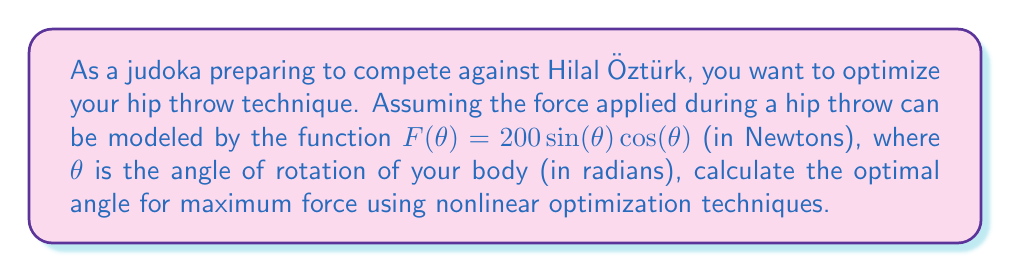Help me with this question. To find the optimal angle for maximum force, we need to maximize the function $F(\theta) = 200\sin(\theta)\cos(\theta)$. Let's approach this step-by-step:

1) First, we can simplify the function using the trigonometric identity $\sin(2\theta) = 2\sin(\theta)\cos(\theta)$:

   $F(\theta) = 200\sin(\theta)\cos(\theta) = 100\sin(2\theta)$

2) To find the maximum, we need to find where the derivative of $F(\theta)$ equals zero:

   $F'(\theta) = 100(2\cos(2\theta)) = 200\cos(2\theta)$

3) Set this equal to zero:

   $200\cos(2\theta) = 0$
   $\cos(2\theta) = 0$

4) The cosine function is zero when its argument is $\frac{\pi}{2}$ or $\frac{3\pi}{2}$. So:

   $2\theta = \frac{\pi}{2}$ or $2\theta = \frac{3\pi}{2}$
   $\theta = \frac{\pi}{4}$ or $\theta = \frac{3\pi}{4}$

5) To determine which of these gives the maximum (rather than minimum), we can check the second derivative:

   $F''(\theta) = -400\sin(2\theta)$

6) At $\theta = \frac{\pi}{4}$, $F''(\frac{\pi}{4}) = -400\sin(\frac{\pi}{2}) = -400 < 0$, indicating a maximum.
   At $\theta = \frac{3\pi}{4}$, $F''(\frac{3\pi}{4}) = -400\sin(\frac{3\pi}{2}) = 400 > 0$, indicating a minimum.

Therefore, the optimal angle for maximum force is $\frac{\pi}{4}$ radians or 45 degrees.
Answer: $\frac{\pi}{4}$ radians or 45° 